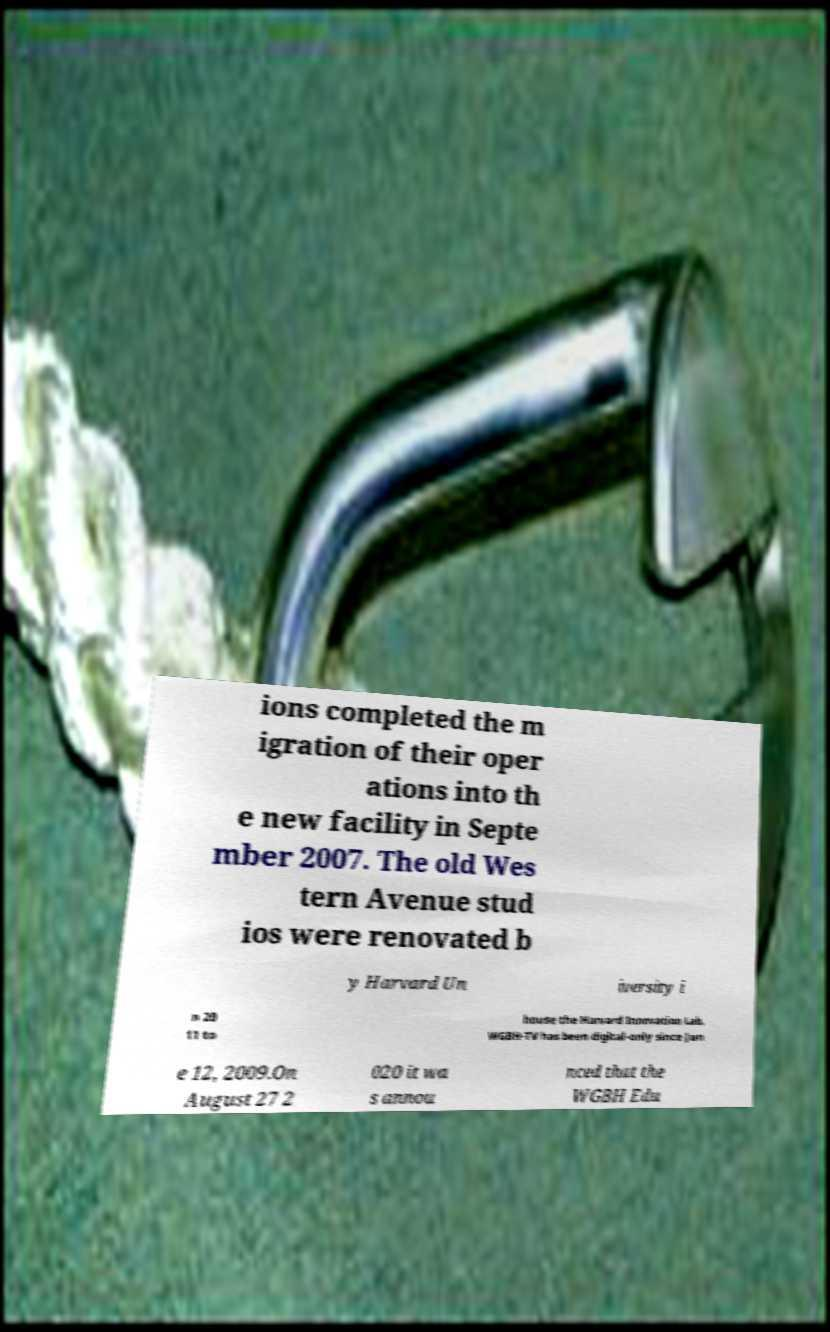What messages or text are displayed in this image? I need them in a readable, typed format. ions completed the m igration of their oper ations into th e new facility in Septe mber 2007. The old Wes tern Avenue stud ios were renovated b y Harvard Un iversity i n 20 11 to house the Harvard Innovation Lab. WGBH-TV has been digital-only since Jun e 12, 2009.On August 27 2 020 it wa s annou nced that the WGBH Edu 